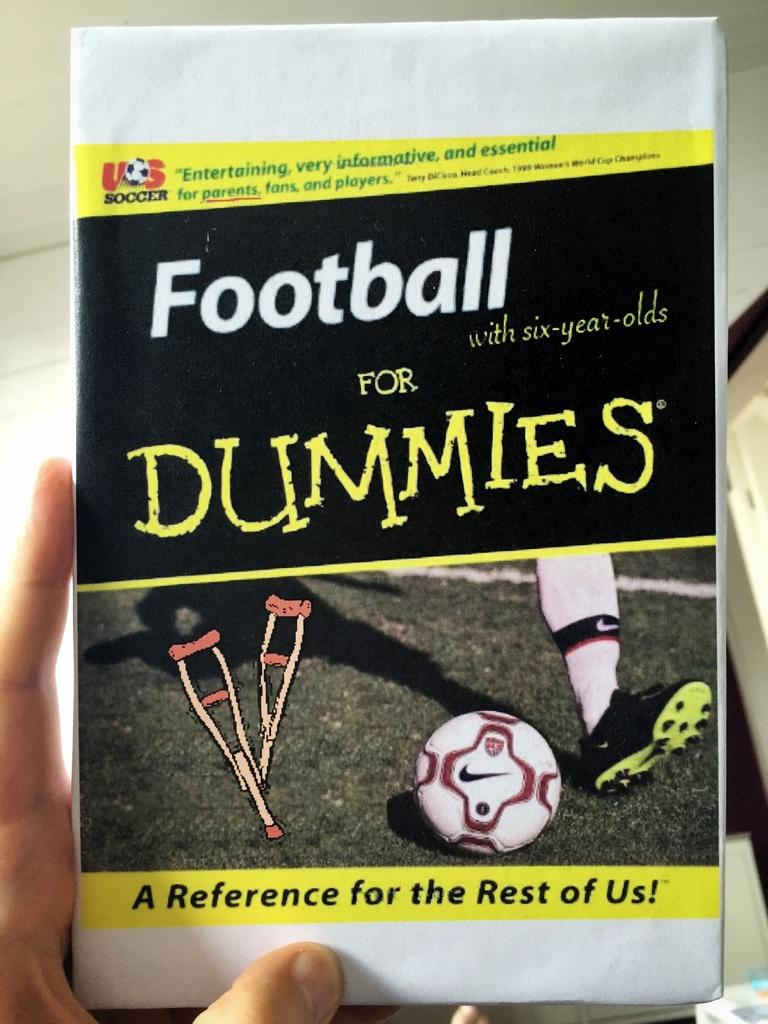<image>
Offer a succinct explanation of the picture presented. the word football is on the front of a book 